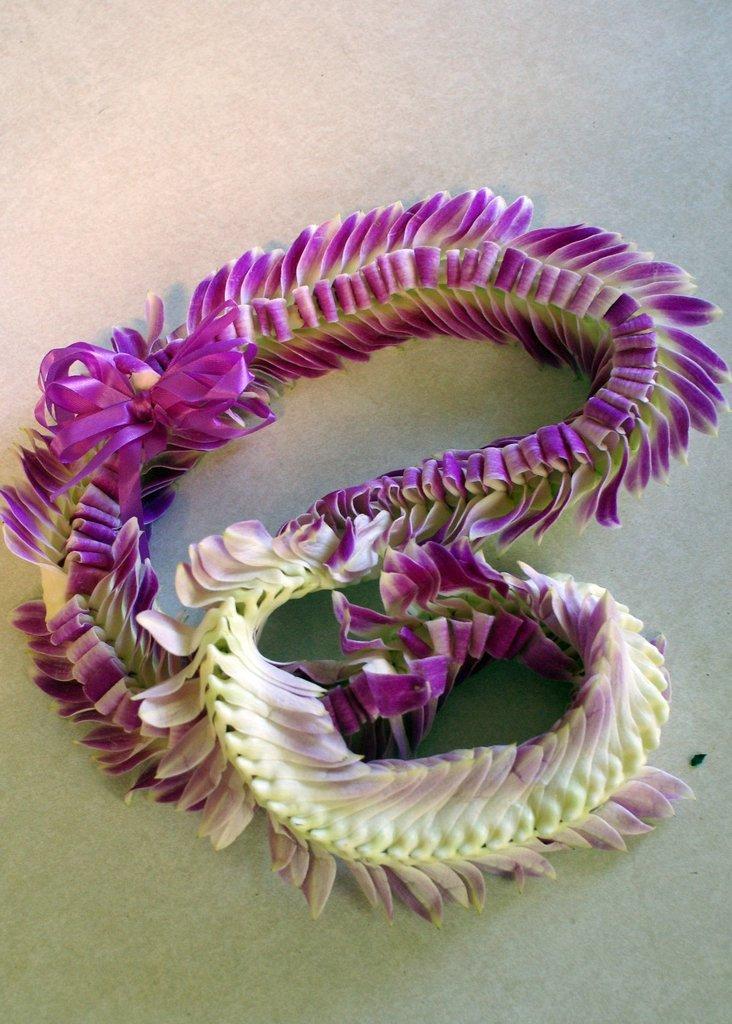In one or two sentences, can you explain what this image depicts? In this picture we can see an object in a yellow and violet color on a white surface. 